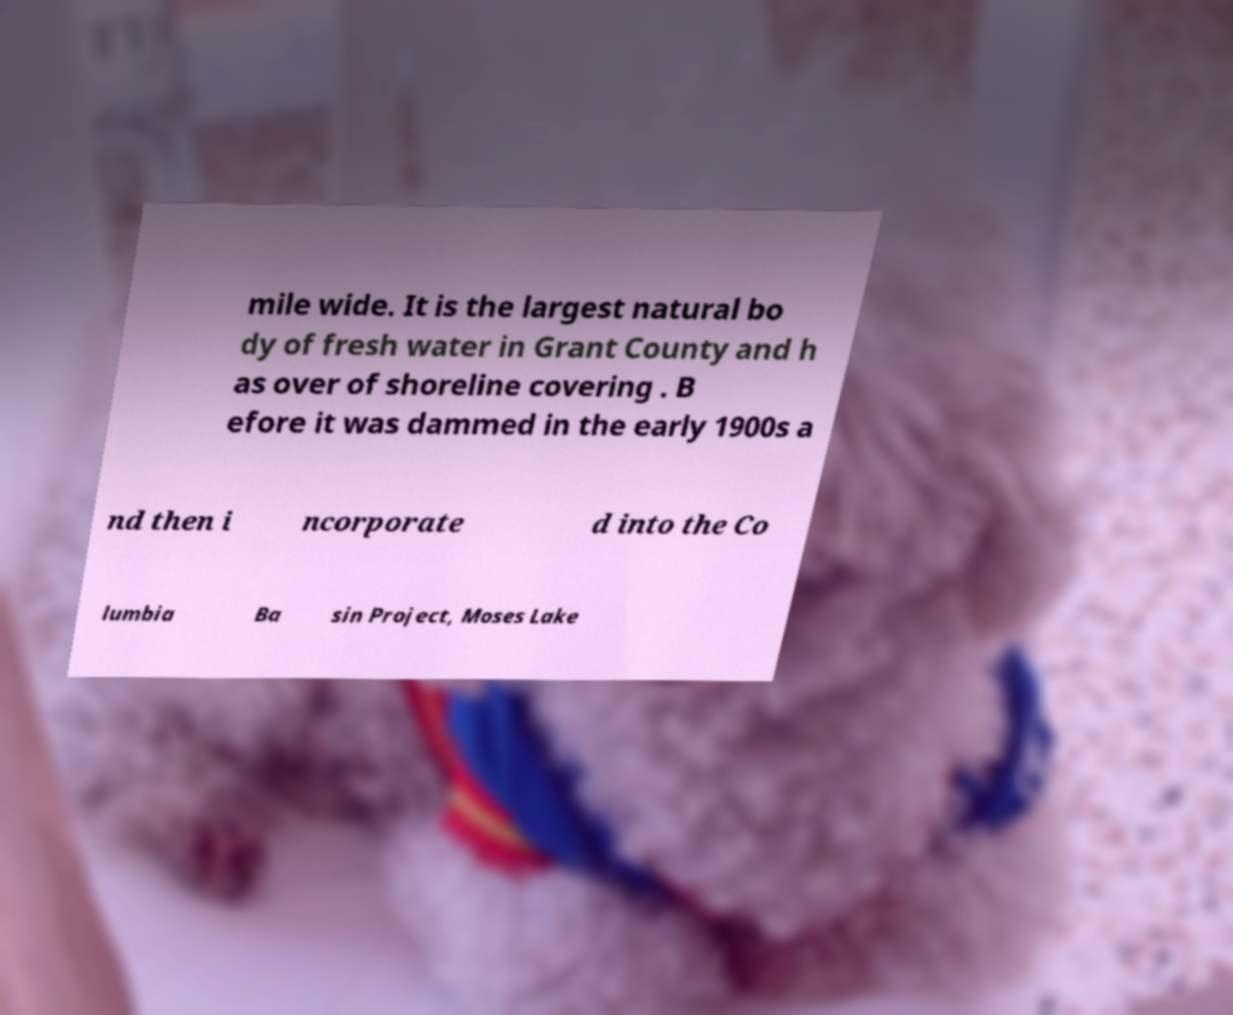There's text embedded in this image that I need extracted. Can you transcribe it verbatim? mile wide. It is the largest natural bo dy of fresh water in Grant County and h as over of shoreline covering . B efore it was dammed in the early 1900s a nd then i ncorporate d into the Co lumbia Ba sin Project, Moses Lake 